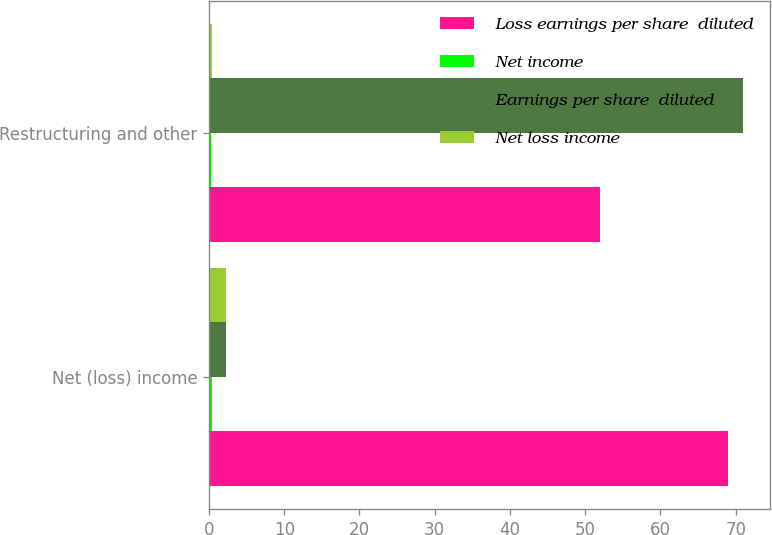<chart> <loc_0><loc_0><loc_500><loc_500><stacked_bar_chart><ecel><fcel>Net (loss) income<fcel>Restructuring and other<nl><fcel>Loss earnings per share  diluted<fcel>69<fcel>52<nl><fcel>Net income<fcel>0.41<fcel>0.31<nl><fcel>Earnings per share  diluted<fcel>2.29<fcel>71<nl><fcel>Net loss income<fcel>2.29<fcel>0.42<nl></chart> 